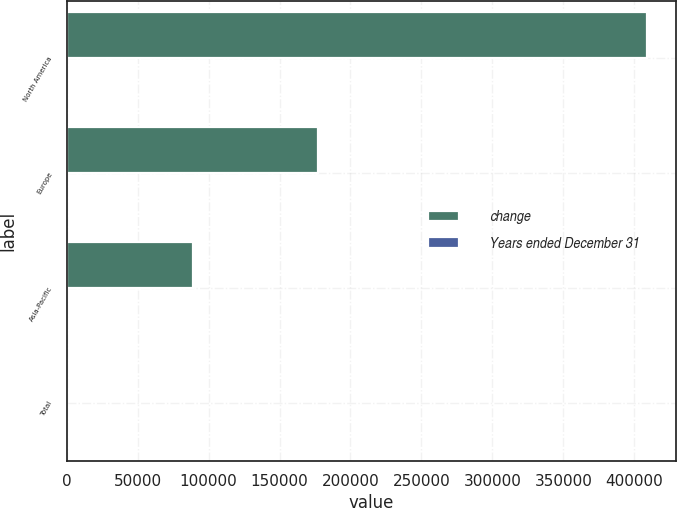Convert chart. <chart><loc_0><loc_0><loc_500><loc_500><stacked_bar_chart><ecel><fcel>North America<fcel>Europe<fcel>Asia-Pacific<fcel>Total<nl><fcel>change<fcel>408769<fcel>176937<fcel>88961<fcel>52<nl><fcel>Years ended December 31<fcel>52<fcel>22<fcel>28<fcel>40<nl></chart> 